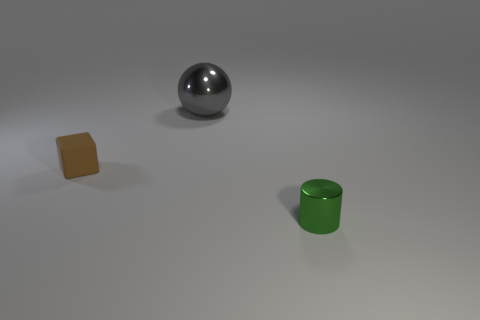Add 2 big gray rubber blocks. How many objects exist? 5 Subtract all cylinders. How many objects are left? 2 Subtract all purple cubes. Subtract all brown spheres. How many cubes are left? 1 Subtract all yellow balls. How many blue cylinders are left? 0 Subtract all green things. Subtract all yellow cylinders. How many objects are left? 2 Add 2 spheres. How many spheres are left? 3 Add 3 brown things. How many brown things exist? 4 Subtract 0 green cubes. How many objects are left? 3 Subtract 1 cylinders. How many cylinders are left? 0 